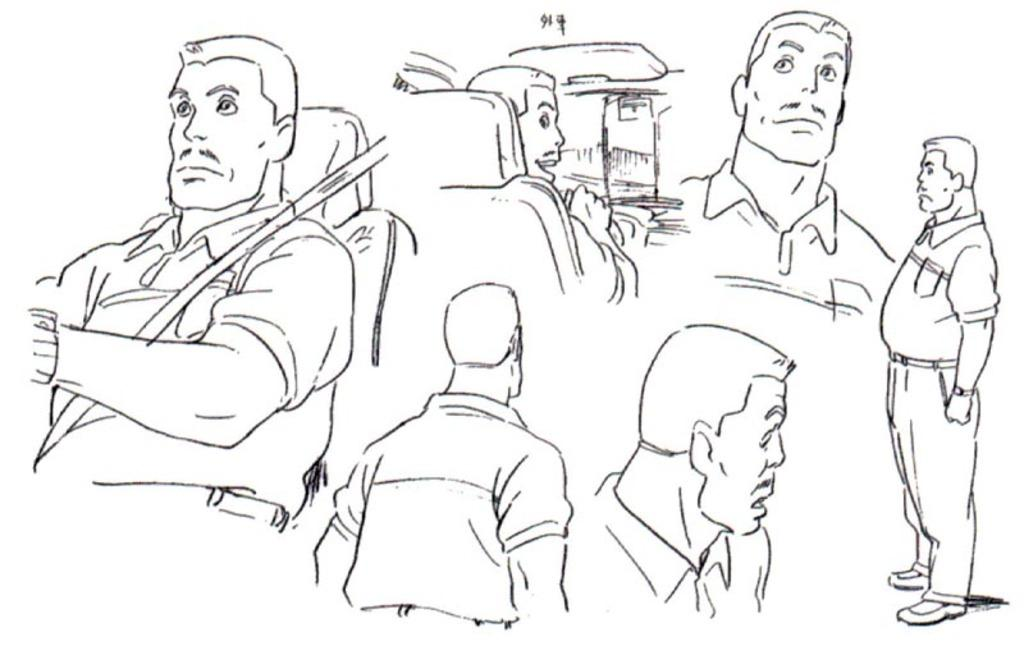What type of artwork is featured in the image? There are handmade drawings in the image. What subject matter is depicted in the drawings? The drawings depict a person. What type of advice is the person in the drawings giving to the pig in the image? There is no pig present in the image, and the person in the drawings is not giving any advice. 